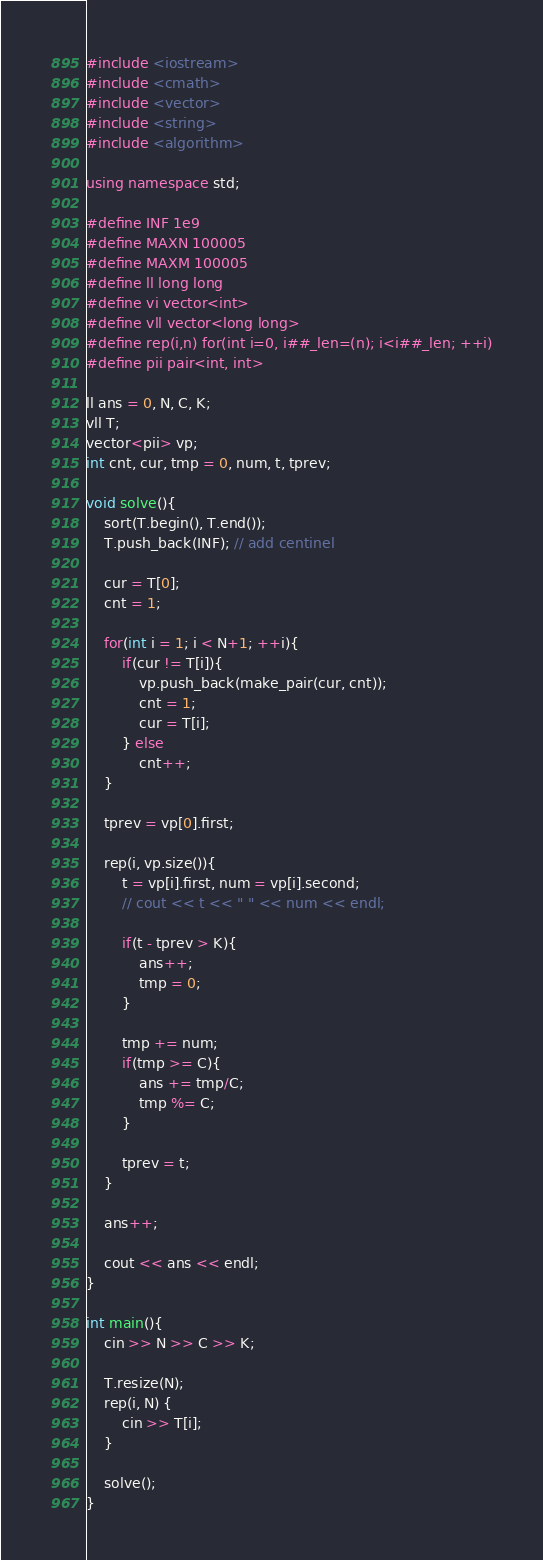<code> <loc_0><loc_0><loc_500><loc_500><_C++_>#include <iostream>
#include <cmath>
#include <vector>
#include <string>
#include <algorithm>

using namespace std;

#define INF 1e9
#define MAXN 100005
#define MAXM 100005
#define ll long long
#define vi vector<int>
#define vll vector<long long>
#define rep(i,n) for(int i=0, i##_len=(n); i<i##_len; ++i)
#define pii pair<int, int>

ll ans = 0, N, C, K;
vll T;
vector<pii> vp;
int cnt, cur, tmp = 0, num, t, tprev;

void solve(){
    sort(T.begin(), T.end());
    T.push_back(INF); // add centinel

    cur = T[0];
    cnt = 1;

    for(int i = 1; i < N+1; ++i){
        if(cur != T[i]){
            vp.push_back(make_pair(cur, cnt));
            cnt = 1;
            cur = T[i];
        } else 
            cnt++;
    }

    tprev = vp[0].first;

    rep(i, vp.size()){
        t = vp[i].first, num = vp[i].second;
        // cout << t << " " << num << endl;

        if(t - tprev > K){
            ans++;
            tmp = 0;
        }

        tmp += num;
        if(tmp >= C){
            ans += tmp/C;
            tmp %= C;
        }

        tprev = t;
    }

    ans++;

    cout << ans << endl;
}

int main(){
    cin >> N >> C >> K;

    T.resize(N);
    rep(i, N) {
        cin >> T[i];
    }

    solve();
}
</code> 